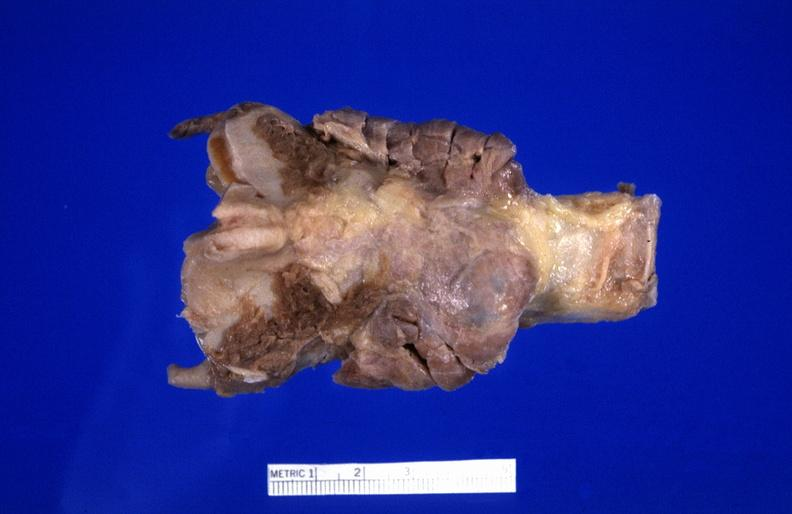what is present?
Answer the question using a single word or phrase. Endocrine 